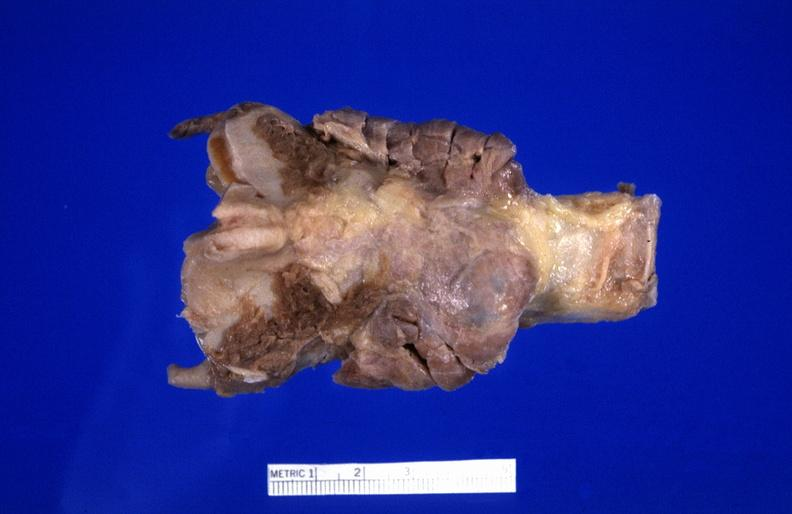what is present?
Answer the question using a single word or phrase. Endocrine 